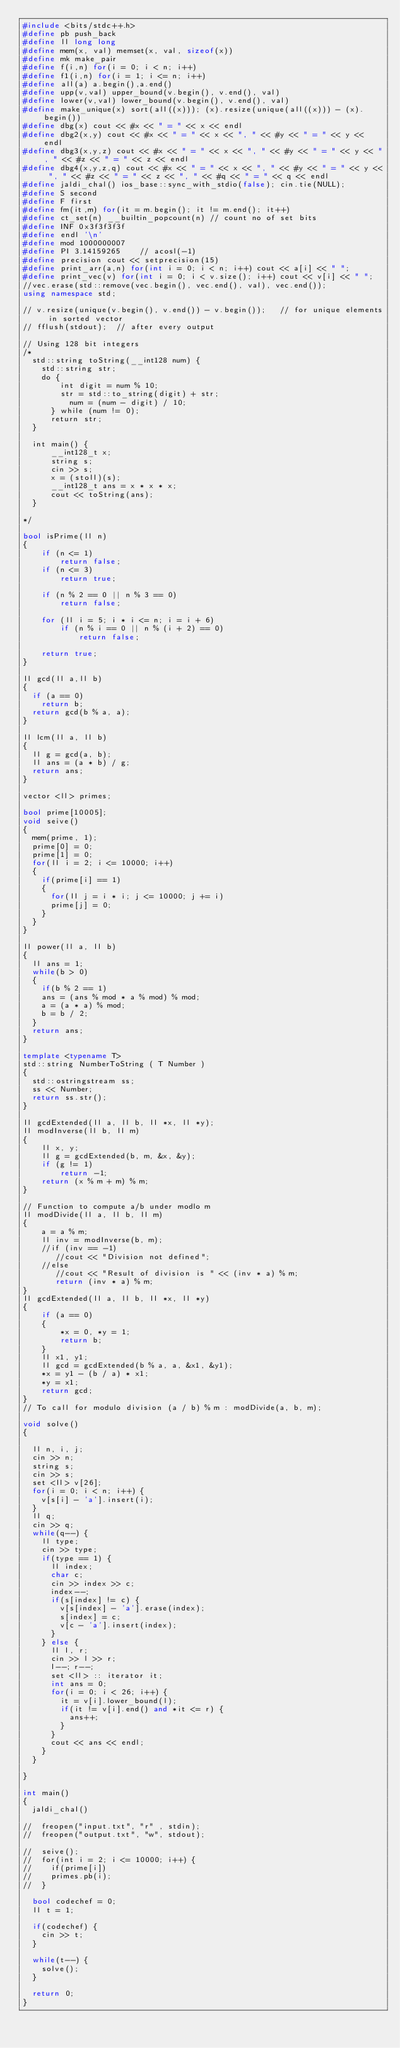<code> <loc_0><loc_0><loc_500><loc_500><_C++_>#include <bits/stdc++.h>
#define pb push_back
#define ll long long
#define mem(x, val) memset(x, val, sizeof(x))
#define mk make_pair
#define f(i,n) for(i = 0; i < n; i++)
#define f1(i,n) for(i = 1; i <= n; i++)
#define all(a) a.begin(),a.end()
#define upp(v,val) upper_bound(v.begin(), v.end(), val)
#define lower(v,val) lower_bound(v.begin(), v.end(), val)
#define make_unique(x) sort(all((x))); (x).resize(unique(all((x))) - (x).begin())
#define dbg(x) cout << #x << " = " << x << endl
#define dbg2(x,y) cout << #x << " = " << x << ", " << #y << " = " << y << endl
#define dbg3(x,y,z) cout << #x << " = " << x << ", " << #y << " = " << y << ", " << #z << " = " << z << endl
#define dbg4(x,y,z,q) cout << #x << " = " << x << ", " << #y << " = " << y << ", " << #z << " = " << z << ", " << #q << " = " << q << endl
#define jaldi_chal() ios_base::sync_with_stdio(false); cin.tie(NULL);
#define S second
#define F first
#define fm(it,m) for(it = m.begin(); it != m.end(); it++)
#define ct_set(n) __builtin_popcount(n) // count no of set bits
#define INF 0x3f3f3f3f
#define endl '\n'
#define mod 1000000007
#define PI 3.14159265    // acosl(-1)
#define precision cout << setprecision(15)
#define print_arr(a,n) for(int i = 0; i < n; i++) cout << a[i] << " ";
#define print_vec(v) for(int i = 0; i < v.size(); i++) cout << v[i] << " ";
//vec.erase(std::remove(vec.begin(), vec.end(), val), vec.end());
using namespace std;

// v.resize(unique(v.begin(), v.end()) - v.begin());   // for unique elements in sorted vector
// fflush(stdout);  // after every output

// Using 128 bit integers
/*
	std::string toString(__int128 num) {
    std::string str;
    do {
        int digit = num % 10;
        str = std::to_string(digit) + str;
	        num = (num - digit) / 10;
	    } while (num != 0);
	    return str;
	}
	
	int main() {
	    __int128_t x;
	    string s;
	    cin >> s;
	    x = (stoll)(s);
	    __int128_t ans = x * x * x;
	    cout << toString(ans);
	}

*/

bool isPrime(ll n)
{
    if (n <= 1)
        return false;
    if (n <= 3)
        return true;
 
    if (n % 2 == 0 || n % 3 == 0)
        return false;
 
    for (ll i = 5; i * i <= n; i = i + 6)
        if (n % i == 0 || n % (i + 2) == 0)
            return false;
 
    return true;
}

ll gcd(ll a,ll b) 
{
	if (a == 0)    
		return b; 	
	return gcd(b % a, a); 
}

ll lcm(ll a, ll b)
{	
	ll g = gcd(a, b); 
	ll ans = (a * b) / g; 
	return ans;	
}

vector <ll> primes;

bool prime[10005];
void seive()
{
	mem(prime, 1);
	prime[0] = 0;
	prime[1] = 0;
	for(ll i = 2; i <= 10000; i++)
	{
		if(prime[i] == 1)
		{
			for(ll j = i * i; j <= 10000; j += i)
			prime[j] = 0;
		}
	}	
}

ll power(ll a, ll b)
{
	ll ans = 1;
	while(b > 0)
	{
		if(b % 2 == 1)
		ans = (ans % mod * a % mod) % mod;
		a = (a * a) % mod;
		b = b / 2;
	}
	return ans;
}

template <typename T>
std::string NumberToString ( T Number )
{
	std::ostringstream ss;
	ss << Number;
	return ss.str();
}

ll gcdExtended(ll a, ll b, ll *x, ll *y);   
ll modInverse(ll b, ll m) 
{ 
    ll x, y; 
    ll g = gcdExtended(b, m, &x, &y); 
    if (g != 1) 
        return -1; 
    return (x % m + m) % m; 
} 
  
// Function to compute a/b under modlo m 
ll modDivide(ll a, ll b, ll m) 
{ 
    a = a % m; 
    ll inv = modInverse(b, m); 
    //if (inv == -1) 
       //cout << "Division not defined"; 
    //else
       //cout << "Result of division is " << (inv * a) % m; 
       return (inv * a) % m;
} 
ll gcdExtended(ll a, ll b, ll *x, ll *y) 
{ 
    if (a == 0) 
    { 
        *x = 0, *y = 1; 
        return b; 
    } 
    ll x1, y1; 
    ll gcd = gcdExtended(b % a, a, &x1, &y1); 
    *x = y1 - (b / a) * x1; 
    *y = x1; 
    return gcd; 
} 
// To call for modulo division (a / b) % m : modDivide(a, b, m);

void solve()
{
	
	ll n, i, j;
	cin >> n;
	string s;
	cin >> s;
	set <ll> v[26];
	for(i = 0; i < n; i++) {
		v[s[i] - 'a'].insert(i);
	}
	ll q;
	cin >> q;
	while(q--) {
		ll type;
		cin >> type;
		if(type == 1) {
			ll index;
			char c;
			cin >> index >> c;
			index--;
			if(s[index] != c) {
				v[s[index] - 'a'].erase(index);
				s[index] = c;
				v[c - 'a'].insert(index);
			}
		} else {
			ll l, r;
			cin >> l >> r;
			l--; r--;
			set <ll> :: iterator it;
			int ans = 0;
			for(i = 0; i < 26; i++) {
				it = v[i].lower_bound(l);
				if(it != v[i].end() and *it <= r) {
					ans++;
				}
			}
			cout << ans << endl;
		}
	}
	
}

int main()
{
	jaldi_chal()
	
//	freopen("input.txt", "r" , stdin);
//  freopen("output.txt", "w", stdout);
	
//	seive();
//	for(int i = 2; i <= 10000; i++)	{
//		if(prime[i])
//		primes.pb(i);
//	}
	
	bool codechef = 0;
	ll t = 1;
	
	if(codechef) {
		cin >> t;
	}
	
	while(t--) {
		solve();
	}
	
	return 0;
}</code> 